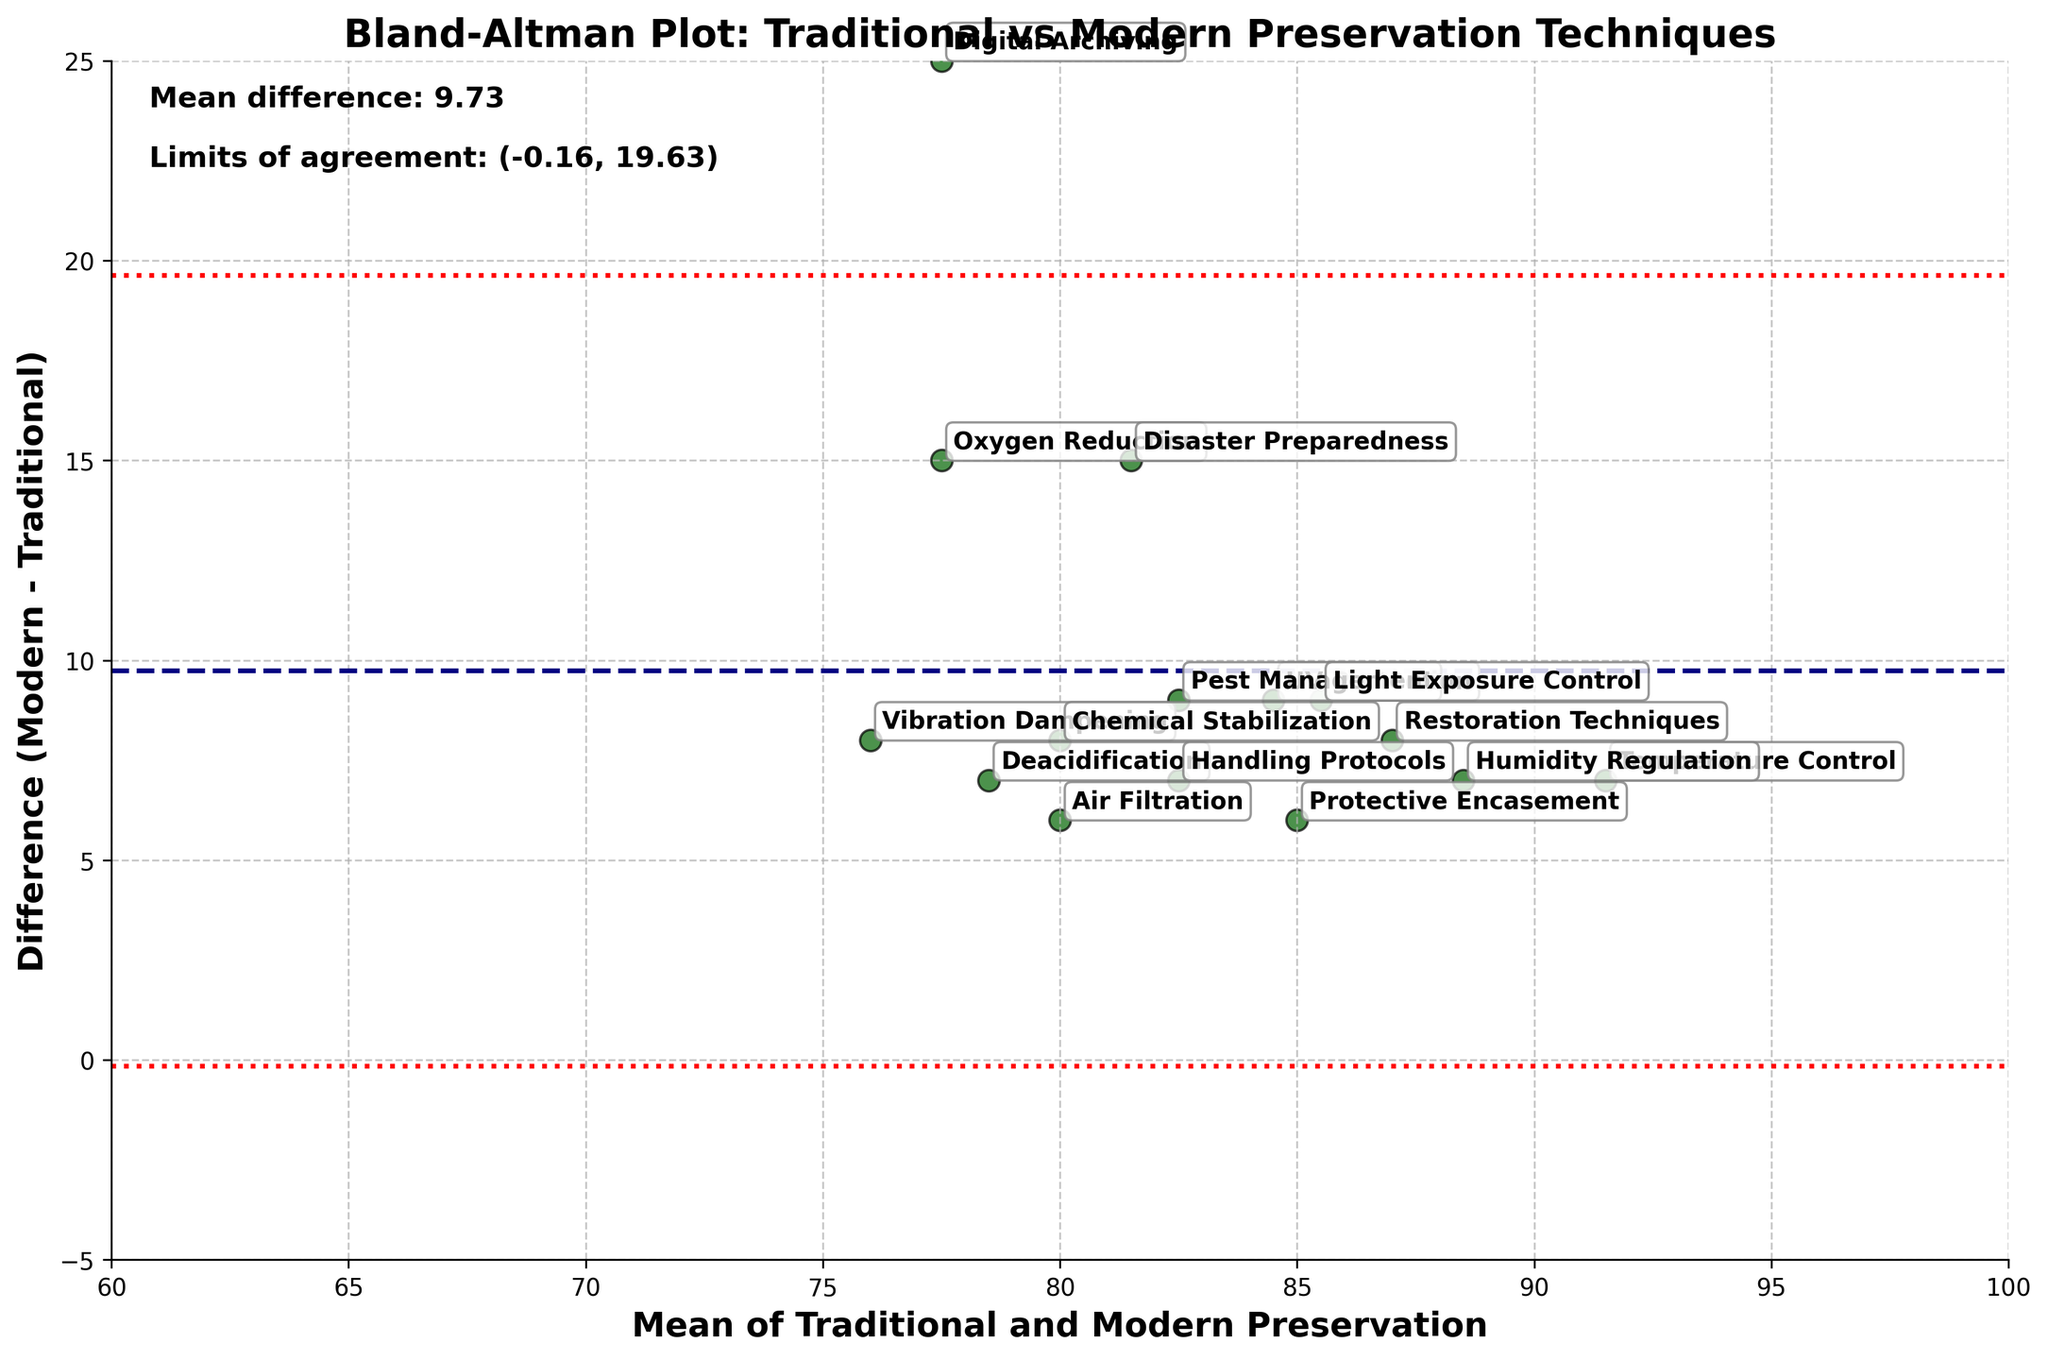What is the title of the plot? The title is usually displayed at the top of the plot. In this case, it reads "Bland-Altman Plot: Traditional vs Modern Preservation Techniques".
Answer: Bland-Altman Plot: Traditional vs Modern Preservation Techniques What do the x-axis and y-axis represent? The x-axis is labeled as "Mean of Traditional and Modern Preservation", while the y-axis is labeled as "Difference (Modern - Traditional)". These descriptions are given directly in the labels of the axes.
Answer: Mean of Traditional and Modern Preservation (x-axis), Difference (Modern - Traditional) (y-axis) How many data points are represented in the plot? Each preservation method is represented as a distinct data point. By counting the number of preservation methods annotated in the plot, we can determine there are 15 data points.
Answer: 15 What is the color of the scatter points for the preservation techniques? The scatter points for the preservation techniques are colored in dark green, which is described in the initial plot setup.
Answer: Dark green What are the mean difference and the limits of agreement as shown in the plot? The mean difference is shown as a navy dashed line and numerically as a text label on the plot. The limits of agreement are the red dotted lines and their values are also labeled on the plot.
Answer: Mean difference: 8.60, Limits of agreement: (6.11, 11.09) Which preservation technique shows the biggest positive difference between modern and traditional preservation? To find the biggest positive difference, look at the data points that have the highest y-axis values. "Digital Archiving" has the highest difference.
Answer: Digital Archiving Which preservation technique has the smallest positive difference between modern and traditional preservation? By examining the data points with the lowest y-axis values, "Vibration Dampening" shows the smallest positive difference in the plot.
Answer: Vibration Dampening What is the mean difference for "UV Protection"? Identify "UV Protection" on the plot and check its y-axis value, which represents the difference between modern and traditional preservation for this method.
Answer: 9 Are there any preservation methods above the upper limit of agreement? If yes, which one(s)? Look at the data points above the red dotted line marking the upper limit of agreement. Here, "Digital Archiving" and "Disaster Preparedness" lie beyond that limit.
Answer: Digital Archiving, Disaster Preparedness 